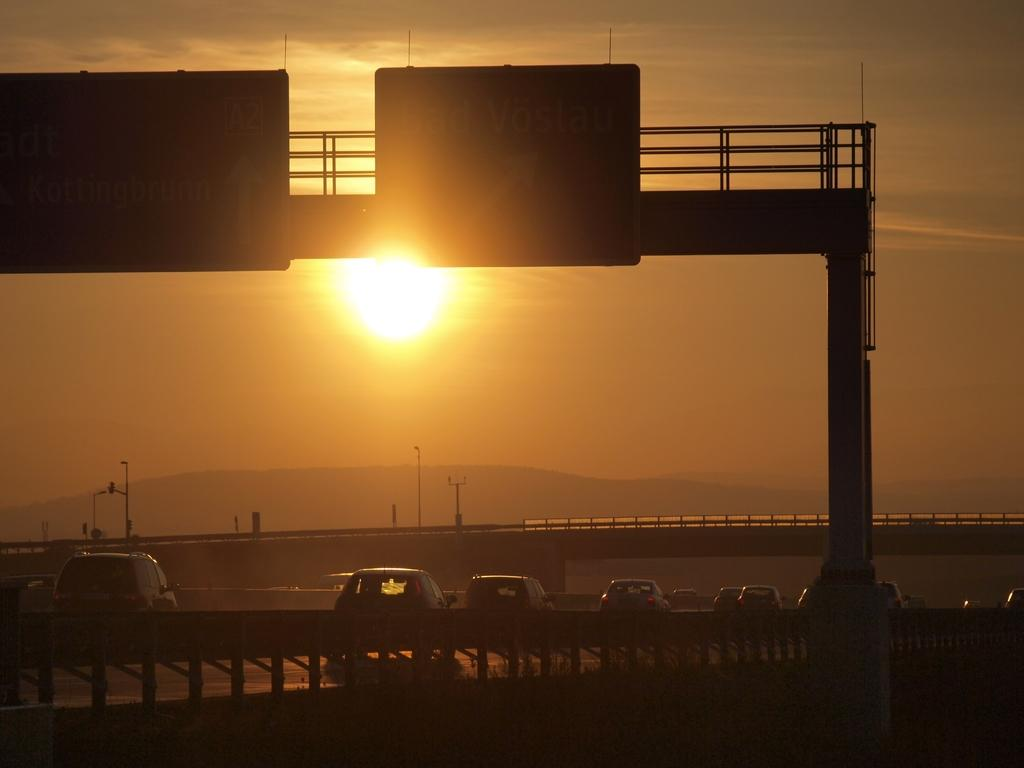What is happening on the road in the image? Vehicles are on the road in the image. What can be seen besides the road in the image? There are signboards, bridges, poles, and a mountain visible in the image. What is the condition of the sky in the image? The sun is visible in the sky in the image. What type of flesh can be seen on the ground in the image? There is no flesh present on the ground in the image. Are there any animals playing in the image? There is no indication of animals playing in the image. 